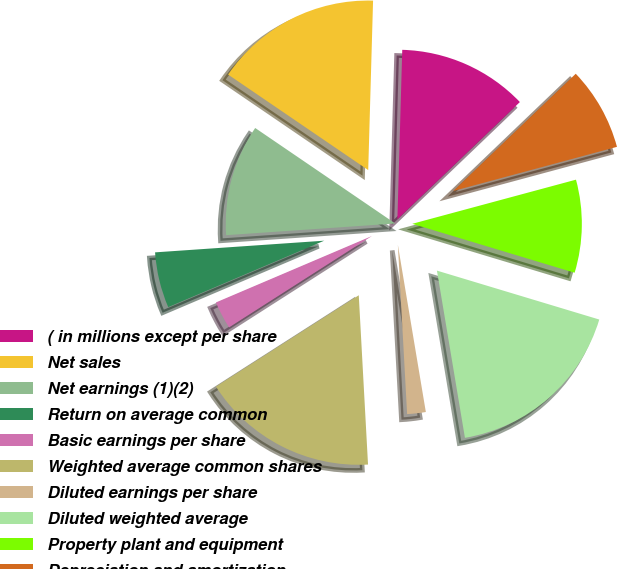Convert chart. <chart><loc_0><loc_0><loc_500><loc_500><pie_chart><fcel>( in millions except per share<fcel>Net sales<fcel>Net earnings (1)(2)<fcel>Return on average common<fcel>Basic earnings per share<fcel>Weighted average common shares<fcel>Diluted earnings per share<fcel>Diluted weighted average<fcel>Property plant and equipment<fcel>Depreciation and amortization<nl><fcel>12.39%<fcel>15.93%<fcel>10.62%<fcel>5.31%<fcel>2.65%<fcel>16.81%<fcel>1.77%<fcel>17.7%<fcel>8.85%<fcel>7.96%<nl></chart> 